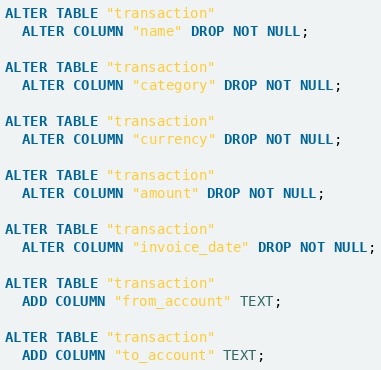<code> <loc_0><loc_0><loc_500><loc_500><_SQL_>ALTER TABLE "transaction"
  ALTER COLUMN "name" DROP NOT NULL;

ALTER TABLE "transaction"
  ALTER COLUMN "category" DROP NOT NULL;

ALTER TABLE "transaction"
  ALTER COLUMN "currency" DROP NOT NULL;

ALTER TABLE "transaction"
  ALTER COLUMN "amount" DROP NOT NULL;

ALTER TABLE "transaction"
  ALTER COLUMN "invoice_date" DROP NOT NULL;

ALTER TABLE "transaction"
  ADD COLUMN "from_account" TEXT;

ALTER TABLE "transaction"
  ADD COLUMN "to_account" TEXT;
</code> 